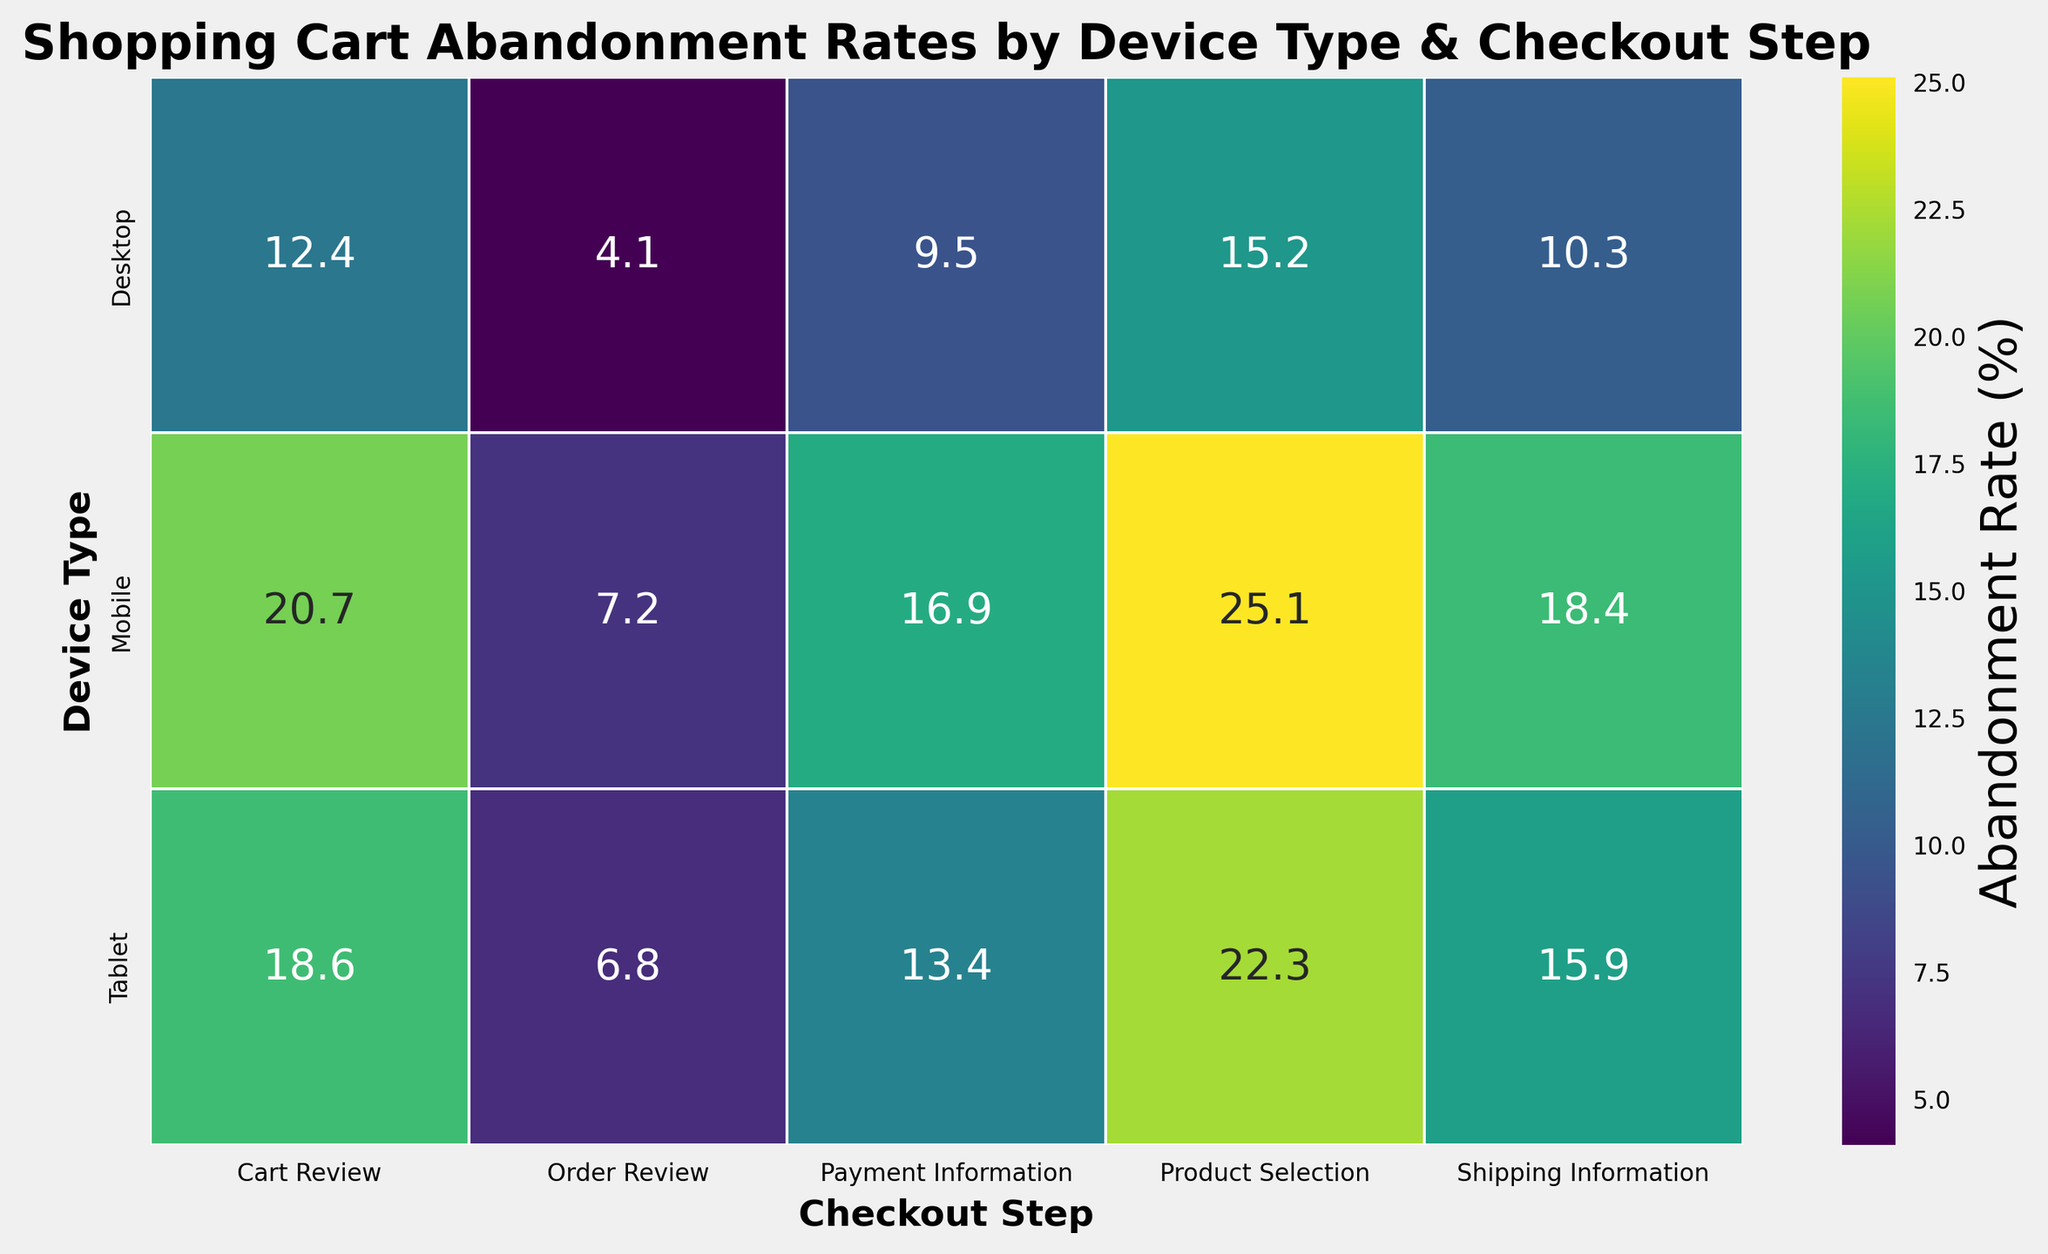What is the abandonment rate at the Payment Information step for Mobile devices? Look at the column labeled 'Payment Information' and find the cell for the 'Mobile' row. The abandonment rate in this cell is 16.9%.
Answer: 16.9% Which device type has the highest overall abandonment rate at the Product Selection step? Compare the cells under the 'Product Selection' column for each device type. Mobile has the highest rate at 25.1%.
Answer: Mobile What is the difference in abandonment rate between Desktop and Tablet devices at the Cart Review step? Find and subtract the abandonment rates for Desktop (12.4%) and Tablet (18.6%) under the 'Cart Review' column. The difference is 18.6% - 12.4% = 6.2%.
Answer: 6.2% Which checkout step has the lowest abandonment rate for any device type? Look for the lowest number across all cells, which is the Desktop device type at the Order Review step with a rate of 4.1%.
Answer: Order Review By how much does the abandonment rate decrease from the Shipping Information to the Order Review step for Desktop devices? Subtract the abandonment rates for these steps: Shipping Information (10.3%) - Order Review (4.1%) = 6.2%.
Answer: 6.2% What general trend do you notice across the checkout steps for all device types? Across all device types, the abandonment rate tends to decrease as users proceed through the checkout steps from Product Selection to Order Review.
Answer: Decrease Comparing the abandonment rates between Mobile and Tablet devices, which device shows a greater drop from Product Selection to Cart Review? Subtract the rates for each device: Mobile (25.1% - 20.7% = 4.4%) and Tablet (22.3% - 18.6% = 3.7%). Mobile shows a greater drop of 4.4%.
Answer: Mobile What is the average abandonment rate for Tablet devices across all checkout steps? Add the abandonment rates for Tablet (22.3 + 18.6 + 15.9 + 13.4 + 6.8 = 77) and divide by 5 steps: 77 / 5 = 15.4%.
Answer: 15.4% Which device type has the smallest abandonment rate at the Shipping Information step? Compare the Shipping Information rates: Desktop (10.3%), Mobile (18.4%), and Tablet (15.9%). Desktop has the smallest rate.
Answer: Desktop At which step does the abandonment rate drop the most for Mobile devices? Calculate the drop between each successive step for Mobile: Product Selection to Cart Review (25.1 - 20.7 = 4.4), Cart Review to Shipping Info (20.7 - 18.4 = 2.3), Shipping Info to Payment Info (18.4 - 16.9 = 1.5), and Payment Info to Order Review (16.9 - 7.2 = 9.7). The biggest drop is from Payment Info to Order Review (9.7%).
Answer: Payment Information to Order Review 